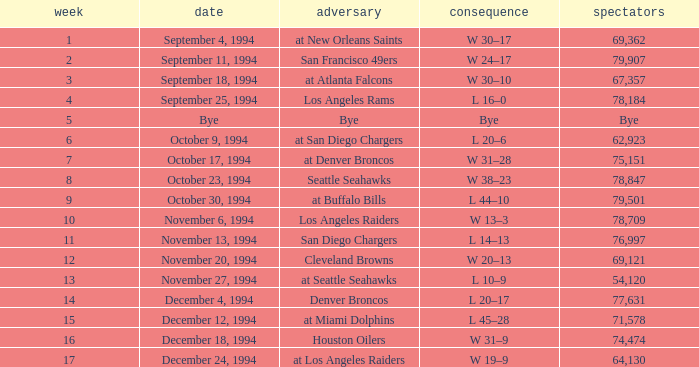What was the score of the Chiefs November 27, 1994 game? L 10–9. 